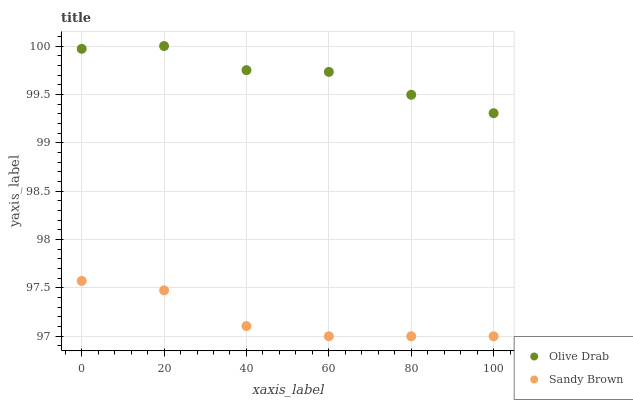Does Sandy Brown have the minimum area under the curve?
Answer yes or no. Yes. Does Olive Drab have the maximum area under the curve?
Answer yes or no. Yes. Does Olive Drab have the minimum area under the curve?
Answer yes or no. No. Is Sandy Brown the smoothest?
Answer yes or no. Yes. Is Olive Drab the roughest?
Answer yes or no. Yes. Is Olive Drab the smoothest?
Answer yes or no. No. Does Sandy Brown have the lowest value?
Answer yes or no. Yes. Does Olive Drab have the lowest value?
Answer yes or no. No. Does Olive Drab have the highest value?
Answer yes or no. Yes. Is Sandy Brown less than Olive Drab?
Answer yes or no. Yes. Is Olive Drab greater than Sandy Brown?
Answer yes or no. Yes. Does Sandy Brown intersect Olive Drab?
Answer yes or no. No. 